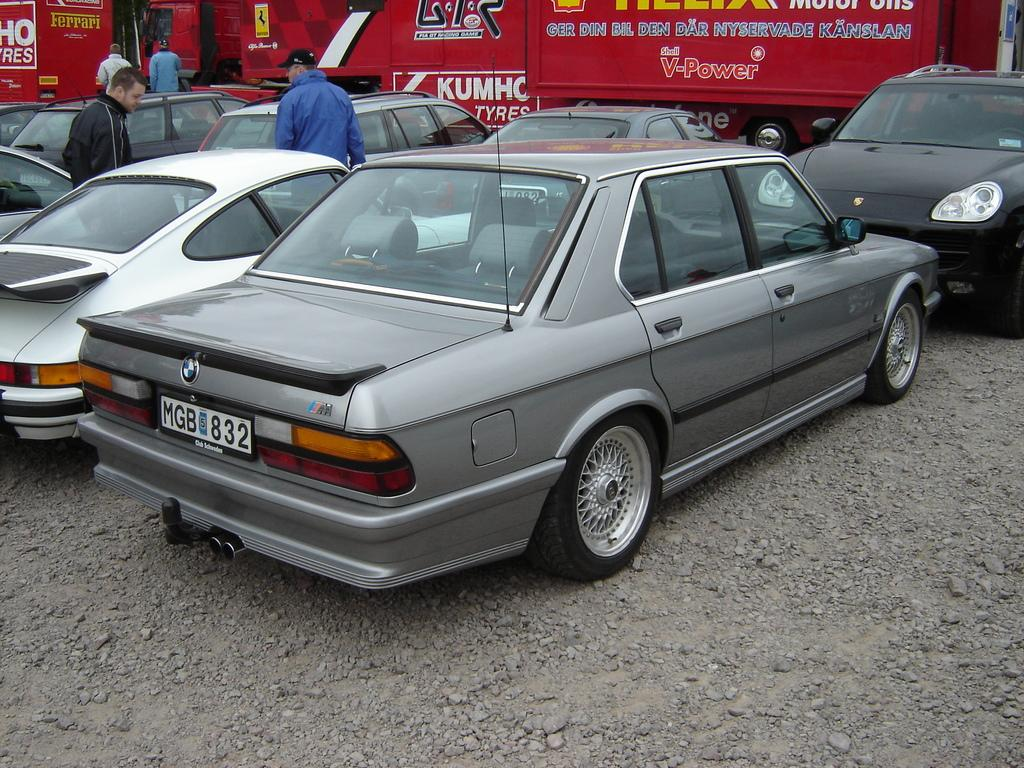What type of vehicles are on the ground in the image? There are cars on the ground in the image. What else can be seen in the background of the image? There are people in the background of the image, and one person is wearing a cap. What other vehicles are visible in the image? There are other vehicles visible in the image. Can you see a guitar being played by someone in the image? There is no guitar present in the image. 